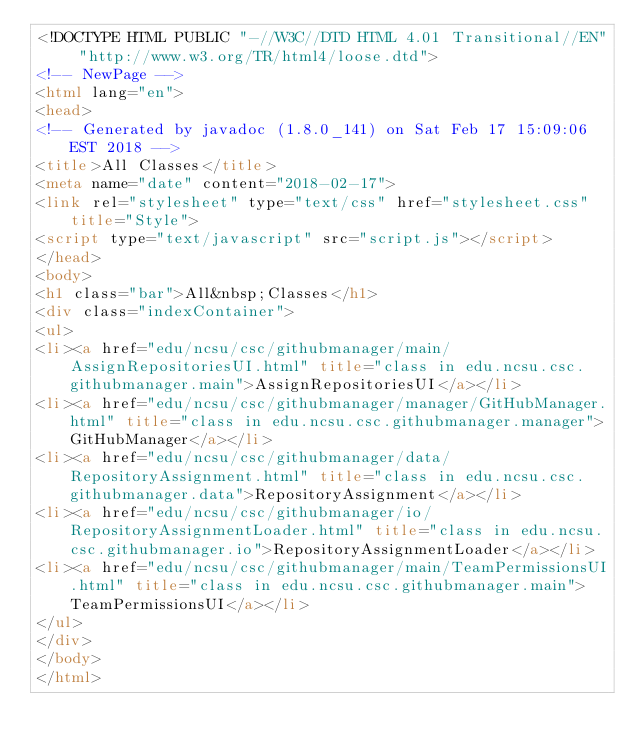<code> <loc_0><loc_0><loc_500><loc_500><_HTML_><!DOCTYPE HTML PUBLIC "-//W3C//DTD HTML 4.01 Transitional//EN" "http://www.w3.org/TR/html4/loose.dtd">
<!-- NewPage -->
<html lang="en">
<head>
<!-- Generated by javadoc (1.8.0_141) on Sat Feb 17 15:09:06 EST 2018 -->
<title>All Classes</title>
<meta name="date" content="2018-02-17">
<link rel="stylesheet" type="text/css" href="stylesheet.css" title="Style">
<script type="text/javascript" src="script.js"></script>
</head>
<body>
<h1 class="bar">All&nbsp;Classes</h1>
<div class="indexContainer">
<ul>
<li><a href="edu/ncsu/csc/githubmanager/main/AssignRepositoriesUI.html" title="class in edu.ncsu.csc.githubmanager.main">AssignRepositoriesUI</a></li>
<li><a href="edu/ncsu/csc/githubmanager/manager/GitHubManager.html" title="class in edu.ncsu.csc.githubmanager.manager">GitHubManager</a></li>
<li><a href="edu/ncsu/csc/githubmanager/data/RepositoryAssignment.html" title="class in edu.ncsu.csc.githubmanager.data">RepositoryAssignment</a></li>
<li><a href="edu/ncsu/csc/githubmanager/io/RepositoryAssignmentLoader.html" title="class in edu.ncsu.csc.githubmanager.io">RepositoryAssignmentLoader</a></li>
<li><a href="edu/ncsu/csc/githubmanager/main/TeamPermissionsUI.html" title="class in edu.ncsu.csc.githubmanager.main">TeamPermissionsUI</a></li>
</ul>
</div>
</body>
</html>
</code> 